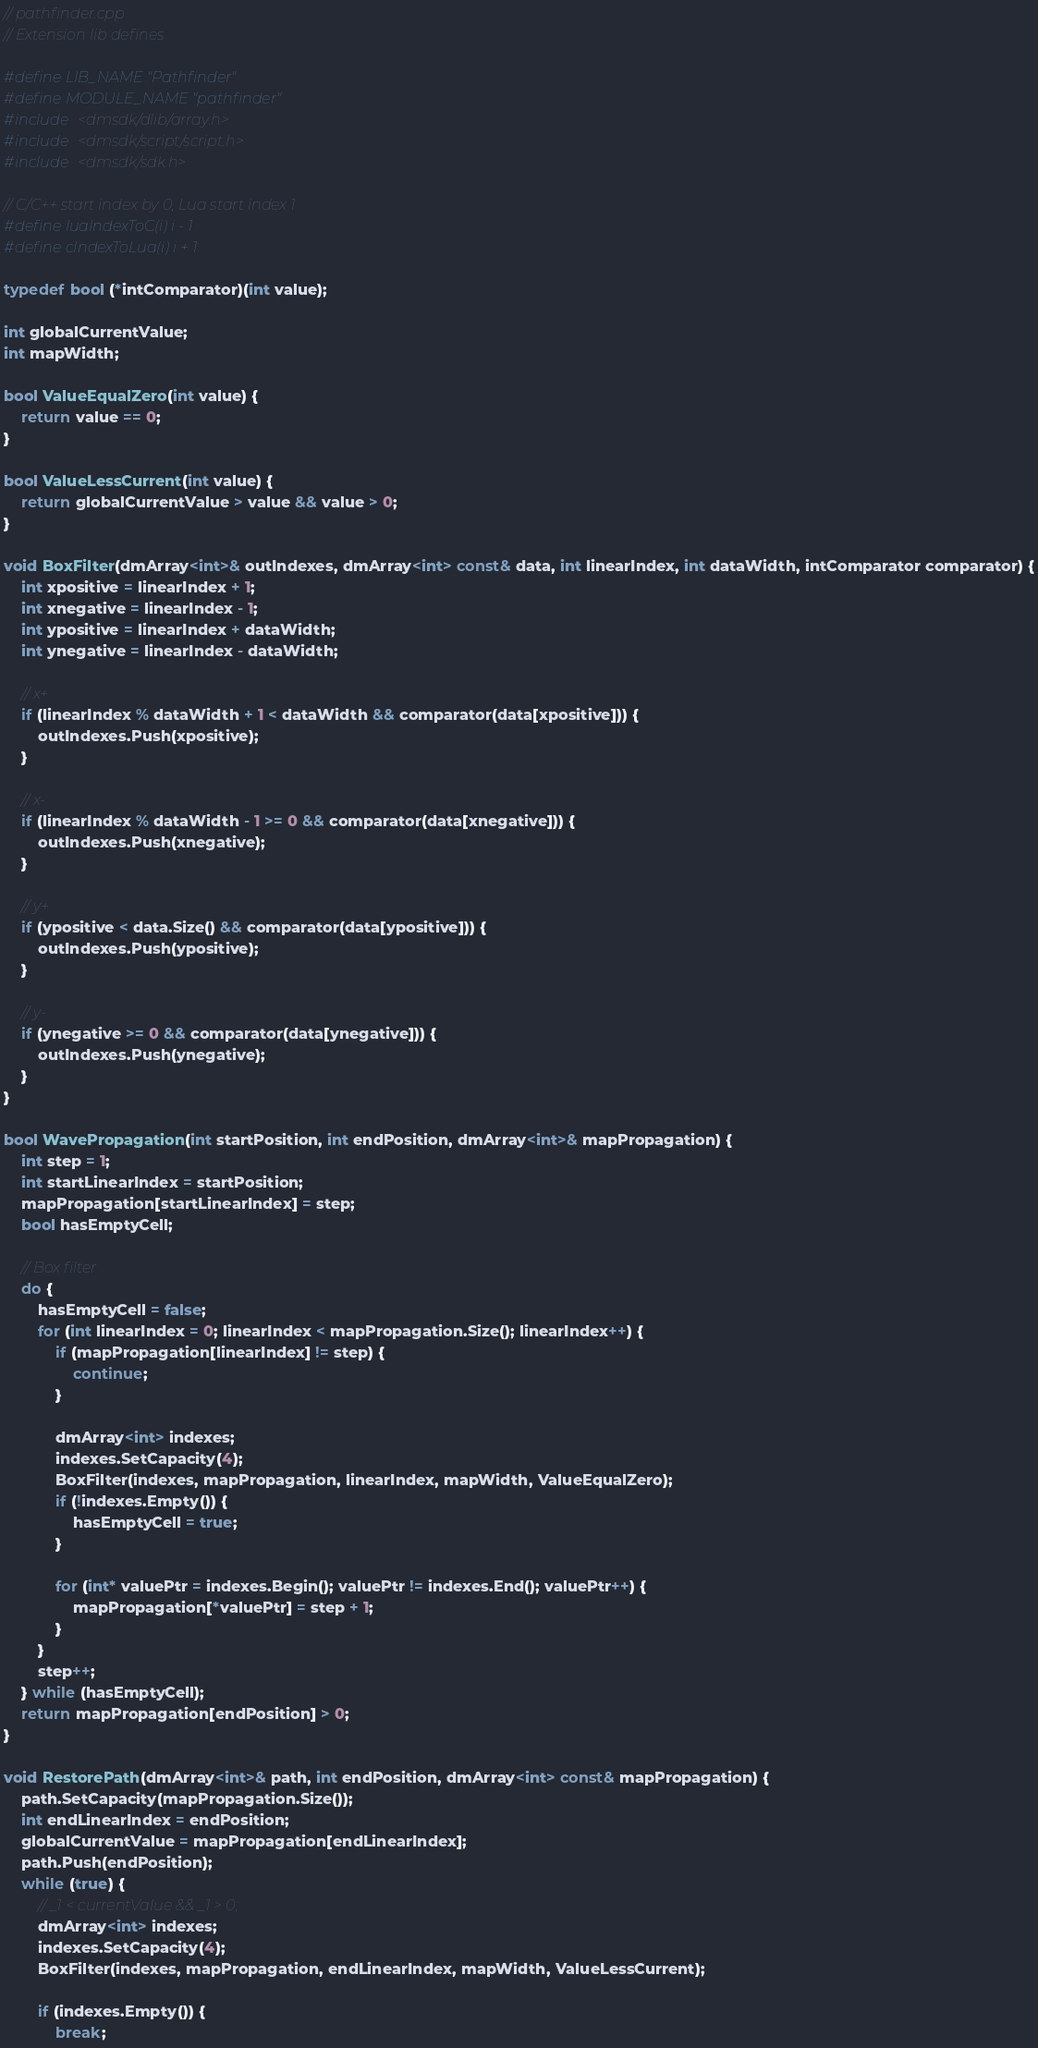<code> <loc_0><loc_0><loc_500><loc_500><_C++_>// pathfinder.cpp
// Extension lib defines

#define LIB_NAME "Pathfinder"
#define MODULE_NAME "pathfinder"
#include <dmsdk/dlib/array.h>
#include <dmsdk/script/script.h>
#include <dmsdk/sdk.h>

// C/C++ start index by 0, Lua start index 1
#define luaIndexToC(i) i - 1 
#define cIndexToLua(i) i + 1

typedef bool (*intComparator)(int value);

int globalCurrentValue;
int mapWidth;

bool ValueEqualZero(int value) {
    return value == 0;
}

bool ValueLessCurrent(int value) {
    return globalCurrentValue > value && value > 0;
}

void BoxFilter(dmArray<int>& outIndexes, dmArray<int> const& data, int linearIndex, int dataWidth, intComparator comparator) {
    int xpositive = linearIndex + 1;
    int xnegative = linearIndex - 1;
    int ypositive = linearIndex + dataWidth;
    int ynegative = linearIndex - dataWidth;

    // x+
    if (linearIndex % dataWidth + 1 < dataWidth && comparator(data[xpositive])) {
        outIndexes.Push(xpositive);
    }

    // x-
    if (linearIndex % dataWidth - 1 >= 0 && comparator(data[xnegative])) {
        outIndexes.Push(xnegative);
    }

    // y+
    if (ypositive < data.Size() && comparator(data[ypositive])) {
        outIndexes.Push(ypositive);
    }

    // y-
    if (ynegative >= 0 && comparator(data[ynegative])) {
        outIndexes.Push(ynegative);
    }
}

bool WavePropagation(int startPosition, int endPosition, dmArray<int>& mapPropagation) {
    int step = 1;
    int startLinearIndex = startPosition;
    mapPropagation[startLinearIndex] = step;
    bool hasEmptyCell;

    // Box filter
    do {
        hasEmptyCell = false;
        for (int linearIndex = 0; linearIndex < mapPropagation.Size(); linearIndex++) {
            if (mapPropagation[linearIndex] != step) {
                continue;
            }

            dmArray<int> indexes;
            indexes.SetCapacity(4);
            BoxFilter(indexes, mapPropagation, linearIndex, mapWidth, ValueEqualZero);
            if (!indexes.Empty()) {
                hasEmptyCell = true;
            }

            for (int* valuePtr = indexes.Begin(); valuePtr != indexes.End(); valuePtr++) {
                mapPropagation[*valuePtr] = step + 1;
            }
        }
        step++;
    } while (hasEmptyCell);
    return mapPropagation[endPosition] > 0;
}

void RestorePath(dmArray<int>& path, int endPosition, dmArray<int> const& mapPropagation) {
    path.SetCapacity(mapPropagation.Size());
    int endLinearIndex = endPosition;
    globalCurrentValue = mapPropagation[endLinearIndex];
    path.Push(endPosition);
    while (true) {
        // _1 < currentValue && _1 > 0;
        dmArray<int> indexes;
        indexes.SetCapacity(4);
        BoxFilter(indexes, mapPropagation, endLinearIndex, mapWidth, ValueLessCurrent);

        if (indexes.Empty()) {
            break;</code> 